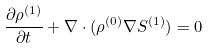<formula> <loc_0><loc_0><loc_500><loc_500>\frac { \partial \rho ^ { ( 1 ) } } { \partial t } + { \nabla } \cdot ( \rho ^ { ( 0 ) } { \nabla } S ^ { ( 1 ) } ) = 0</formula> 